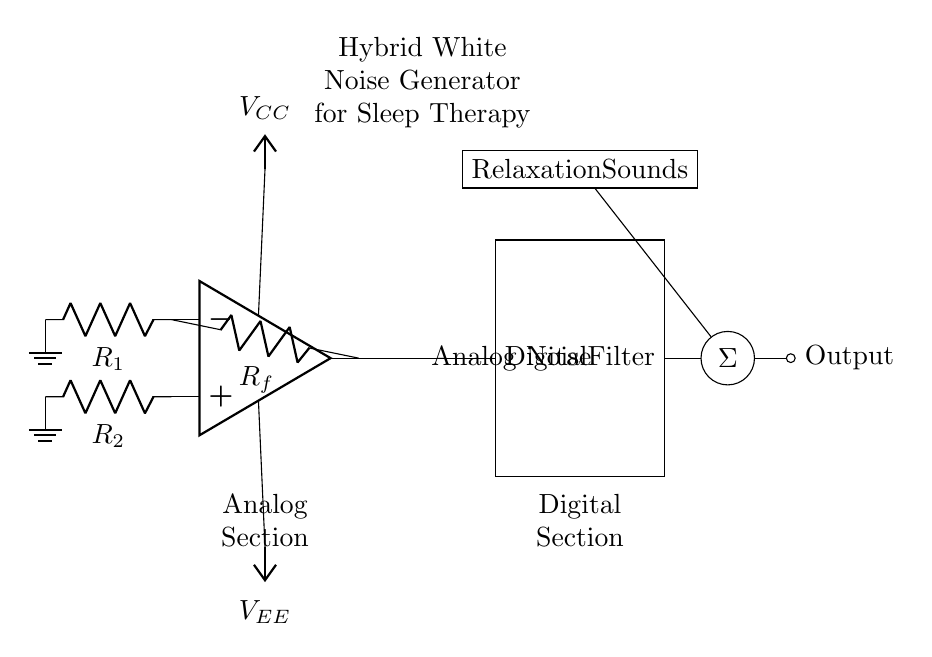What type of circuit is depicted? The circuit is a hybrid white noise generator, combining both analog and digital components for sleep therapy.
Answer: Hybrid white noise generator What does the analog section do? The analog section, consisting of an operational amplifier and resistors, generates white noise by amplifying random electronic noise.
Answer: Generates white noise What is the output labeled as? The output is labeled "Output" at the end of the circuit, indicating where the final sound signal is delivered.
Answer: Output What component serves as the digital filter? The digital filter is represented by a rectangle labeled "Digital Filter," which processes the analog noise.
Answer: Digital Filter What is the function of the mixer? The mixer combines the processed analog noise from the digital filter with additional relaxation sounds before producing the final output.
Answer: Combine sounds What voltage supplies the operational amplifier? The operational amplifier is supplied by a positive voltage labeled VCC, and a negative voltage labeled VEE, indicating a dual power supply.
Answer: VCC and VEE How does additional relaxation sound connect to the circuit? The additional relaxation sounds are connected to the mixer via a direct line, indicating they are mixed with the analog noise input.
Answer: Via a direct connection 